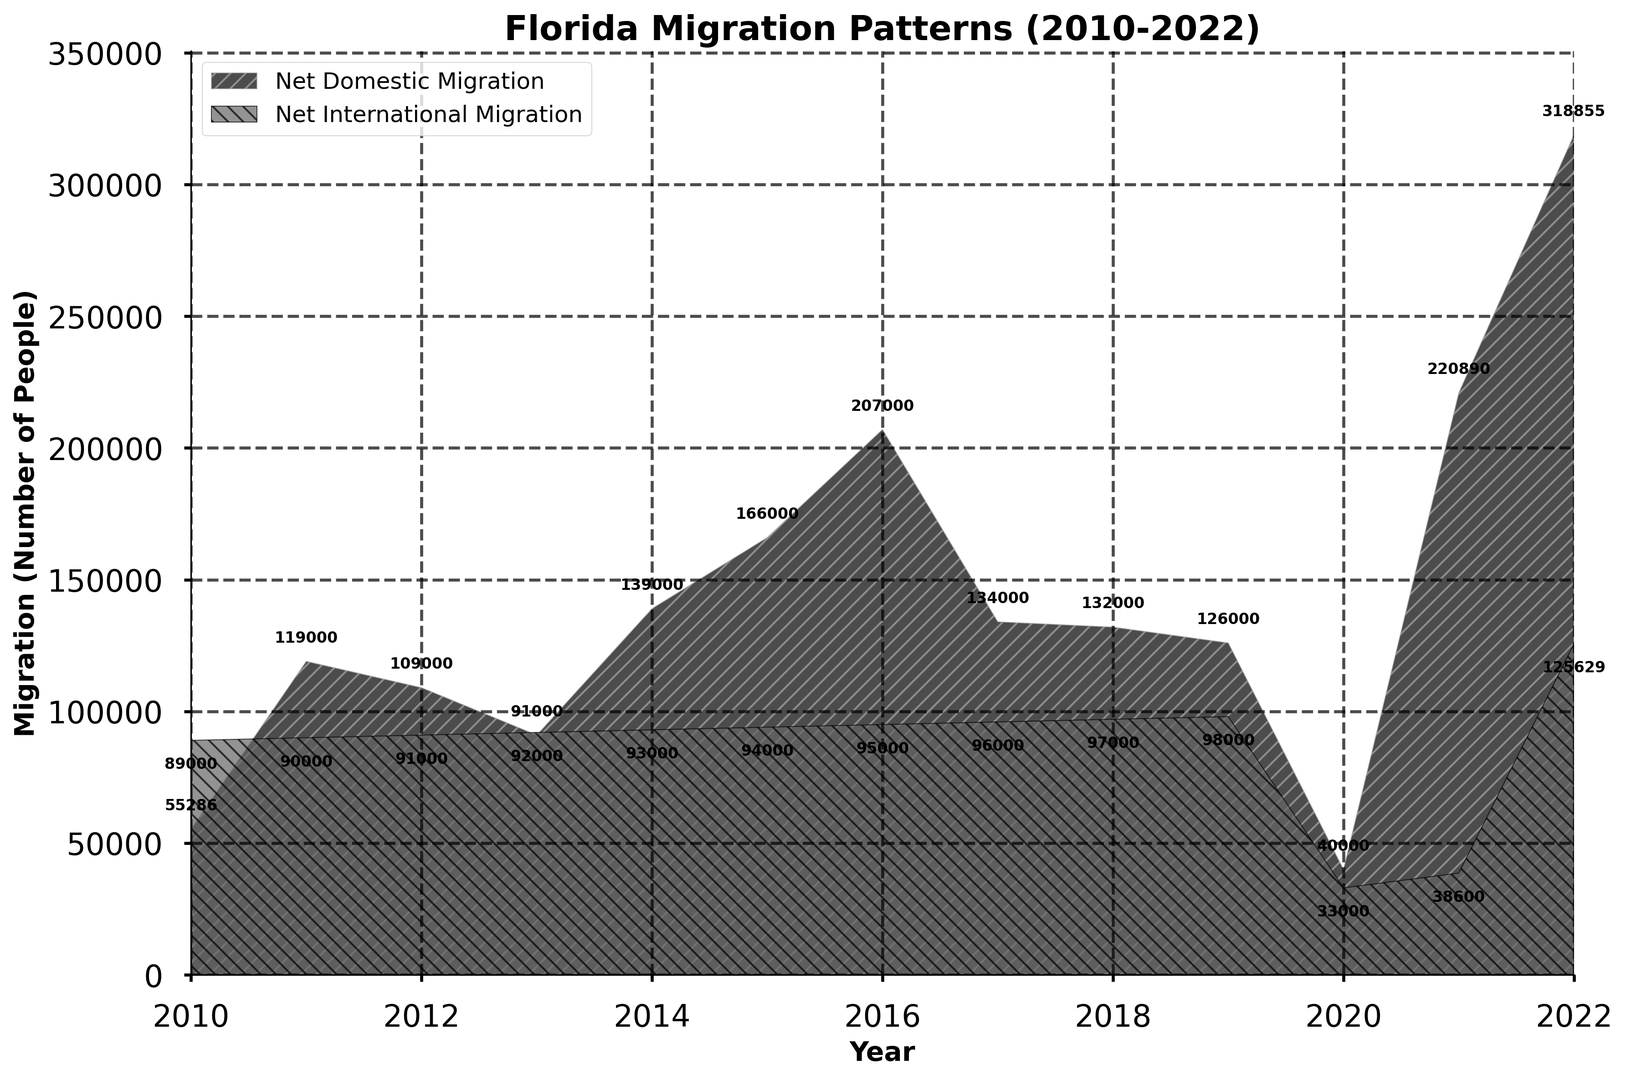What was the net domestic migration in 2015? Look at the figure and locate the value annotated near the area representing net domestic migration for the year 2015. This value will tell us the net domestic migration for that year.
Answer: 166,000 In which year did Florida experience the highest net domestic migration? Observe the tallest point of the area representing net domestic migration and note the corresponding year. This point will indicate the highest net domestic migration.
Answer: 2022 What is the difference between net domestic and net international migration in 2022? Locate the values for both net domestic and net international migration in 2022. Subtract the net international migration value from the net domestic migration value to get the difference. Difference = 318,855 - 125,629.
Answer: 193,226 Which type of migration had a consistently higher amount from 2016 to 2019? For each year from 2016 to 2019, compare the net domestic migration and net international migration values. Determine which type consistently had higher values across these years.
Answer: Net domestic migration By how much did net domestic migration increase from 2020 to 2021? Check the value of net domestic migration in 2020 and 2021. Subtract the 2020 value from the 2021 value to find the increase. Increase = 220,890 - 40,000.
Answer: 180,890 Which year saw the lowest net international migration? Find the shortest part of the area representing net international migration and note the corresponding year. This will be the year with the lowest net international migration.
Answer: 2020 What is the average net international migration for the years 2010 to 2015? Sum the values of net international migration from 2010 to 2015, then divide by the number of years (6) to find the average. Average = (89,000 + 90,000 + 91,000 + 92,000 + 93,000 + 94,000) / 6.
Answer: 91,500 How did net international migration change from 2020 to 2021? Note the values for net international migration in 2020 and 2021. Compare the 2021 value against the 2020 value to determine the change. Change = 38,600 - 33,000.
Answer: Increased by 5,600 